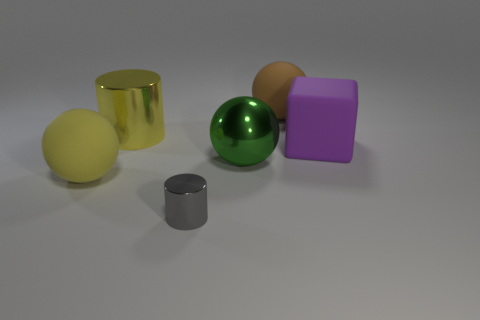How many objects are in front of the big yellow ball and on the right side of the small gray metal object?
Your answer should be very brief. 0. What is the material of the object that is to the right of the green object and behind the purple cube?
Make the answer very short. Rubber. Are there fewer tiny cylinders that are behind the yellow rubber object than matte cubes that are behind the gray cylinder?
Keep it short and to the point. Yes. There is a cube that is made of the same material as the big brown object; what size is it?
Make the answer very short. Large. Is there any other thing of the same color as the block?
Provide a succinct answer. No. Is the material of the big purple thing the same as the big yellow ball that is to the left of the brown ball?
Ensure brevity in your answer.  Yes. There is a gray thing that is the same shape as the yellow shiny thing; what is its material?
Your response must be concise. Metal. Does the brown sphere behind the big yellow cylinder have the same material as the tiny thing in front of the large purple object?
Make the answer very short. No. The matte block behind the object in front of the large matte object that is on the left side of the brown matte sphere is what color?
Your answer should be very brief. Purple. How many other objects are the same shape as the big green thing?
Make the answer very short. 2. 